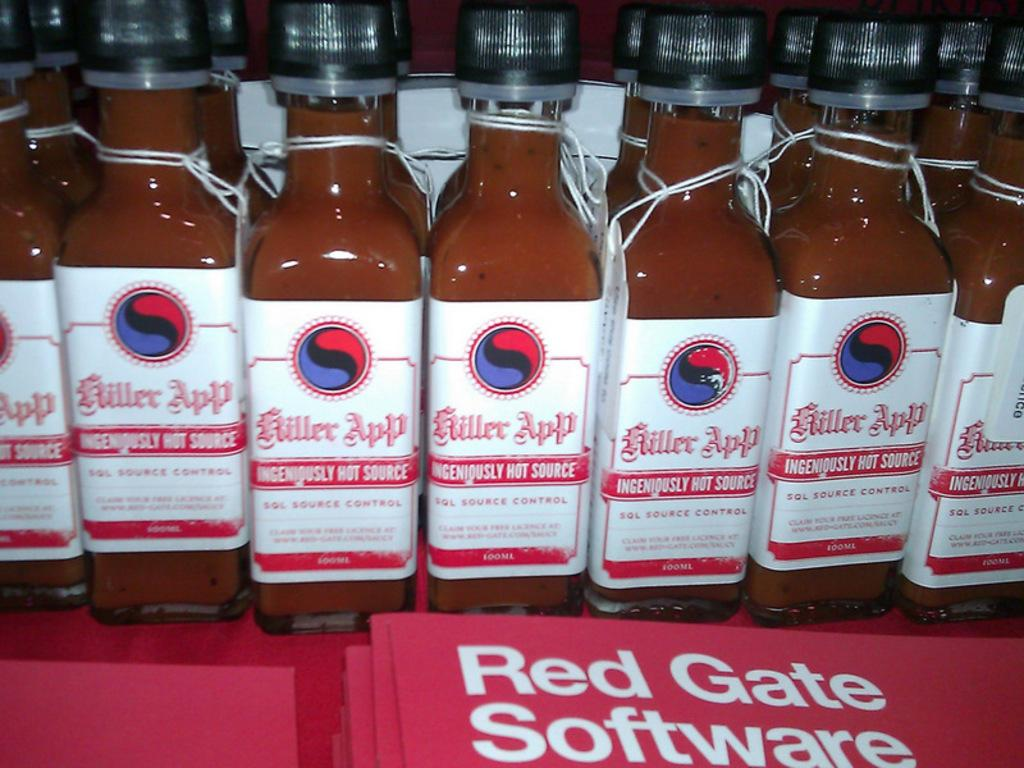<image>
Provide a brief description of the given image. Bottle of Killer app ingeniously hot sauce lined up 